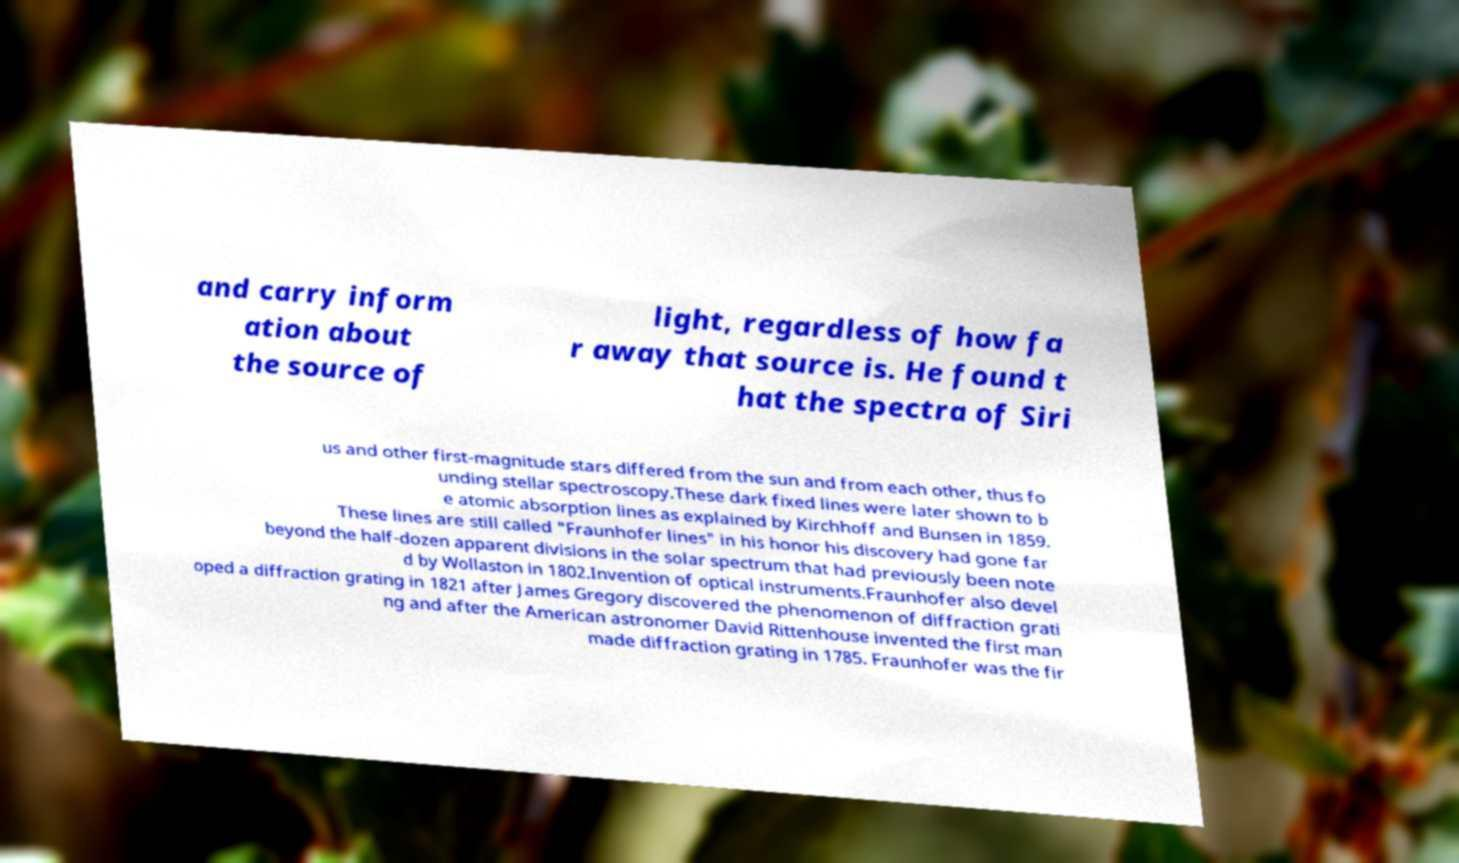I need the written content from this picture converted into text. Can you do that? and carry inform ation about the source of light, regardless of how fa r away that source is. He found t hat the spectra of Siri us and other first-magnitude stars differed from the sun and from each other, thus fo unding stellar spectroscopy.These dark fixed lines were later shown to b e atomic absorption lines as explained by Kirchhoff and Bunsen in 1859. These lines are still called "Fraunhofer lines" in his honor his discovery had gone far beyond the half-dozen apparent divisions in the solar spectrum that had previously been note d by Wollaston in 1802.Invention of optical instruments.Fraunhofer also devel oped a diffraction grating in 1821 after James Gregory discovered the phenomenon of diffraction grati ng and after the American astronomer David Rittenhouse invented the first man made diffraction grating in 1785. Fraunhofer was the fir 